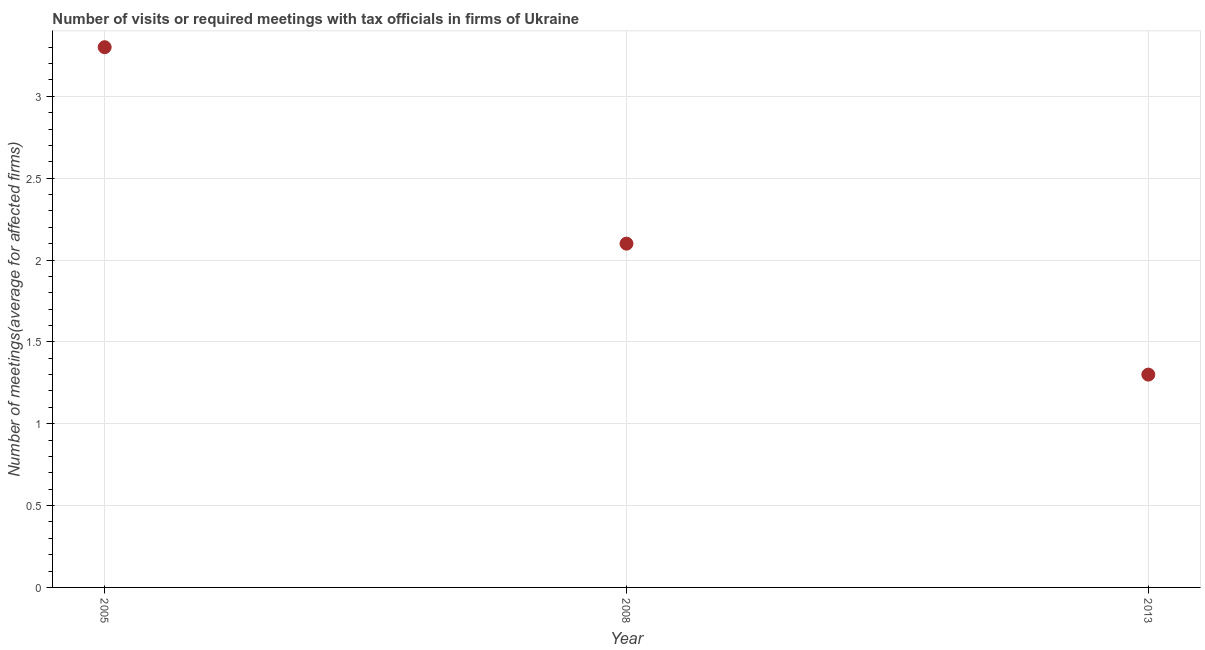What is the number of required meetings with tax officials in 2008?
Ensure brevity in your answer.  2.1. Across all years, what is the minimum number of required meetings with tax officials?
Ensure brevity in your answer.  1.3. What is the difference between the number of required meetings with tax officials in 2005 and 2013?
Provide a succinct answer. 2. What is the average number of required meetings with tax officials per year?
Give a very brief answer. 2.23. Do a majority of the years between 2013 and 2005 (inclusive) have number of required meetings with tax officials greater than 3.2 ?
Make the answer very short. No. What is the ratio of the number of required meetings with tax officials in 2008 to that in 2013?
Offer a very short reply. 1.62. Is the number of required meetings with tax officials in 2005 less than that in 2008?
Ensure brevity in your answer.  No. Is the difference between the number of required meetings with tax officials in 2008 and 2013 greater than the difference between any two years?
Provide a short and direct response. No. What is the difference between the highest and the second highest number of required meetings with tax officials?
Your response must be concise. 1.2. Is the sum of the number of required meetings with tax officials in 2005 and 2008 greater than the maximum number of required meetings with tax officials across all years?
Keep it short and to the point. Yes. What is the difference between the highest and the lowest number of required meetings with tax officials?
Give a very brief answer. 2. How many dotlines are there?
Your answer should be very brief. 1. Are the values on the major ticks of Y-axis written in scientific E-notation?
Offer a terse response. No. Does the graph contain any zero values?
Ensure brevity in your answer.  No. Does the graph contain grids?
Ensure brevity in your answer.  Yes. What is the title of the graph?
Your answer should be very brief. Number of visits or required meetings with tax officials in firms of Ukraine. What is the label or title of the X-axis?
Make the answer very short. Year. What is the label or title of the Y-axis?
Keep it short and to the point. Number of meetings(average for affected firms). What is the Number of meetings(average for affected firms) in 2013?
Ensure brevity in your answer.  1.3. What is the ratio of the Number of meetings(average for affected firms) in 2005 to that in 2008?
Offer a terse response. 1.57. What is the ratio of the Number of meetings(average for affected firms) in 2005 to that in 2013?
Offer a very short reply. 2.54. What is the ratio of the Number of meetings(average for affected firms) in 2008 to that in 2013?
Your answer should be very brief. 1.61. 